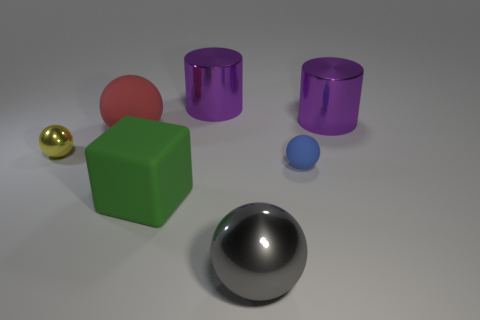Is the size of the metal thing on the left side of the red rubber object the same as the green matte thing?
Provide a succinct answer. No. There is a thing that is on the right side of the large gray metallic ball and in front of the yellow shiny thing; what shape is it?
Keep it short and to the point. Sphere. What color is the big sphere that is in front of the sphere behind the tiny sphere left of the small blue sphere?
Give a very brief answer. Gray. The large matte object that is the same shape as the small yellow metallic thing is what color?
Offer a terse response. Red. Is the number of large purple metal objects that are behind the red object the same as the number of red matte things?
Give a very brief answer. No. How many balls are large gray things or blue things?
Provide a short and direct response. 2. There is a ball that is made of the same material as the red thing; what color is it?
Provide a short and direct response. Blue. Is the material of the big green cube the same as the big sphere to the right of the big red thing?
Ensure brevity in your answer.  No. How many objects are gray cylinders or big matte balls?
Your answer should be compact. 1. Are there any large red matte things that have the same shape as the yellow thing?
Ensure brevity in your answer.  Yes. 